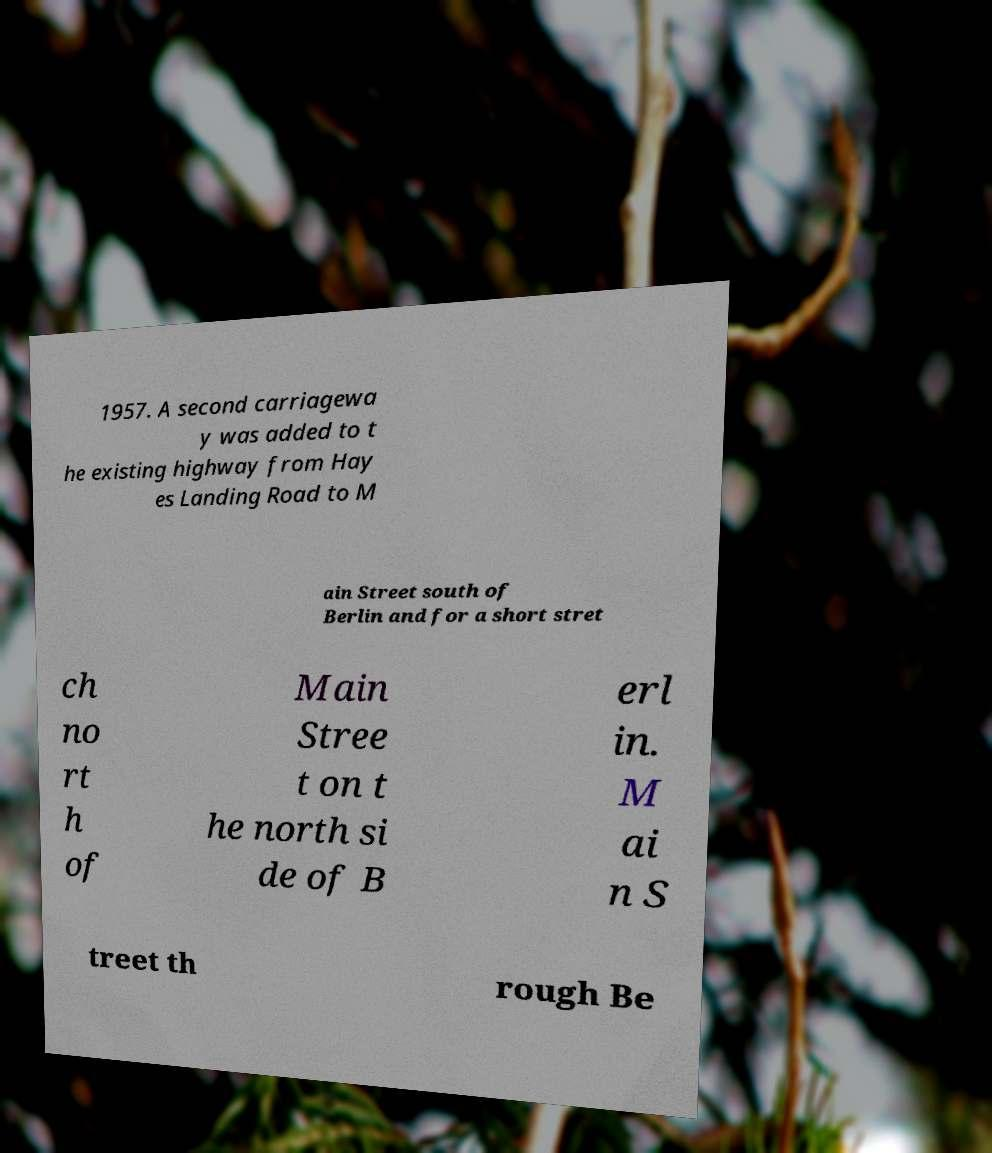Please identify and transcribe the text found in this image. 1957. A second carriagewa y was added to t he existing highway from Hay es Landing Road to M ain Street south of Berlin and for a short stret ch no rt h of Main Stree t on t he north si de of B erl in. M ai n S treet th rough Be 